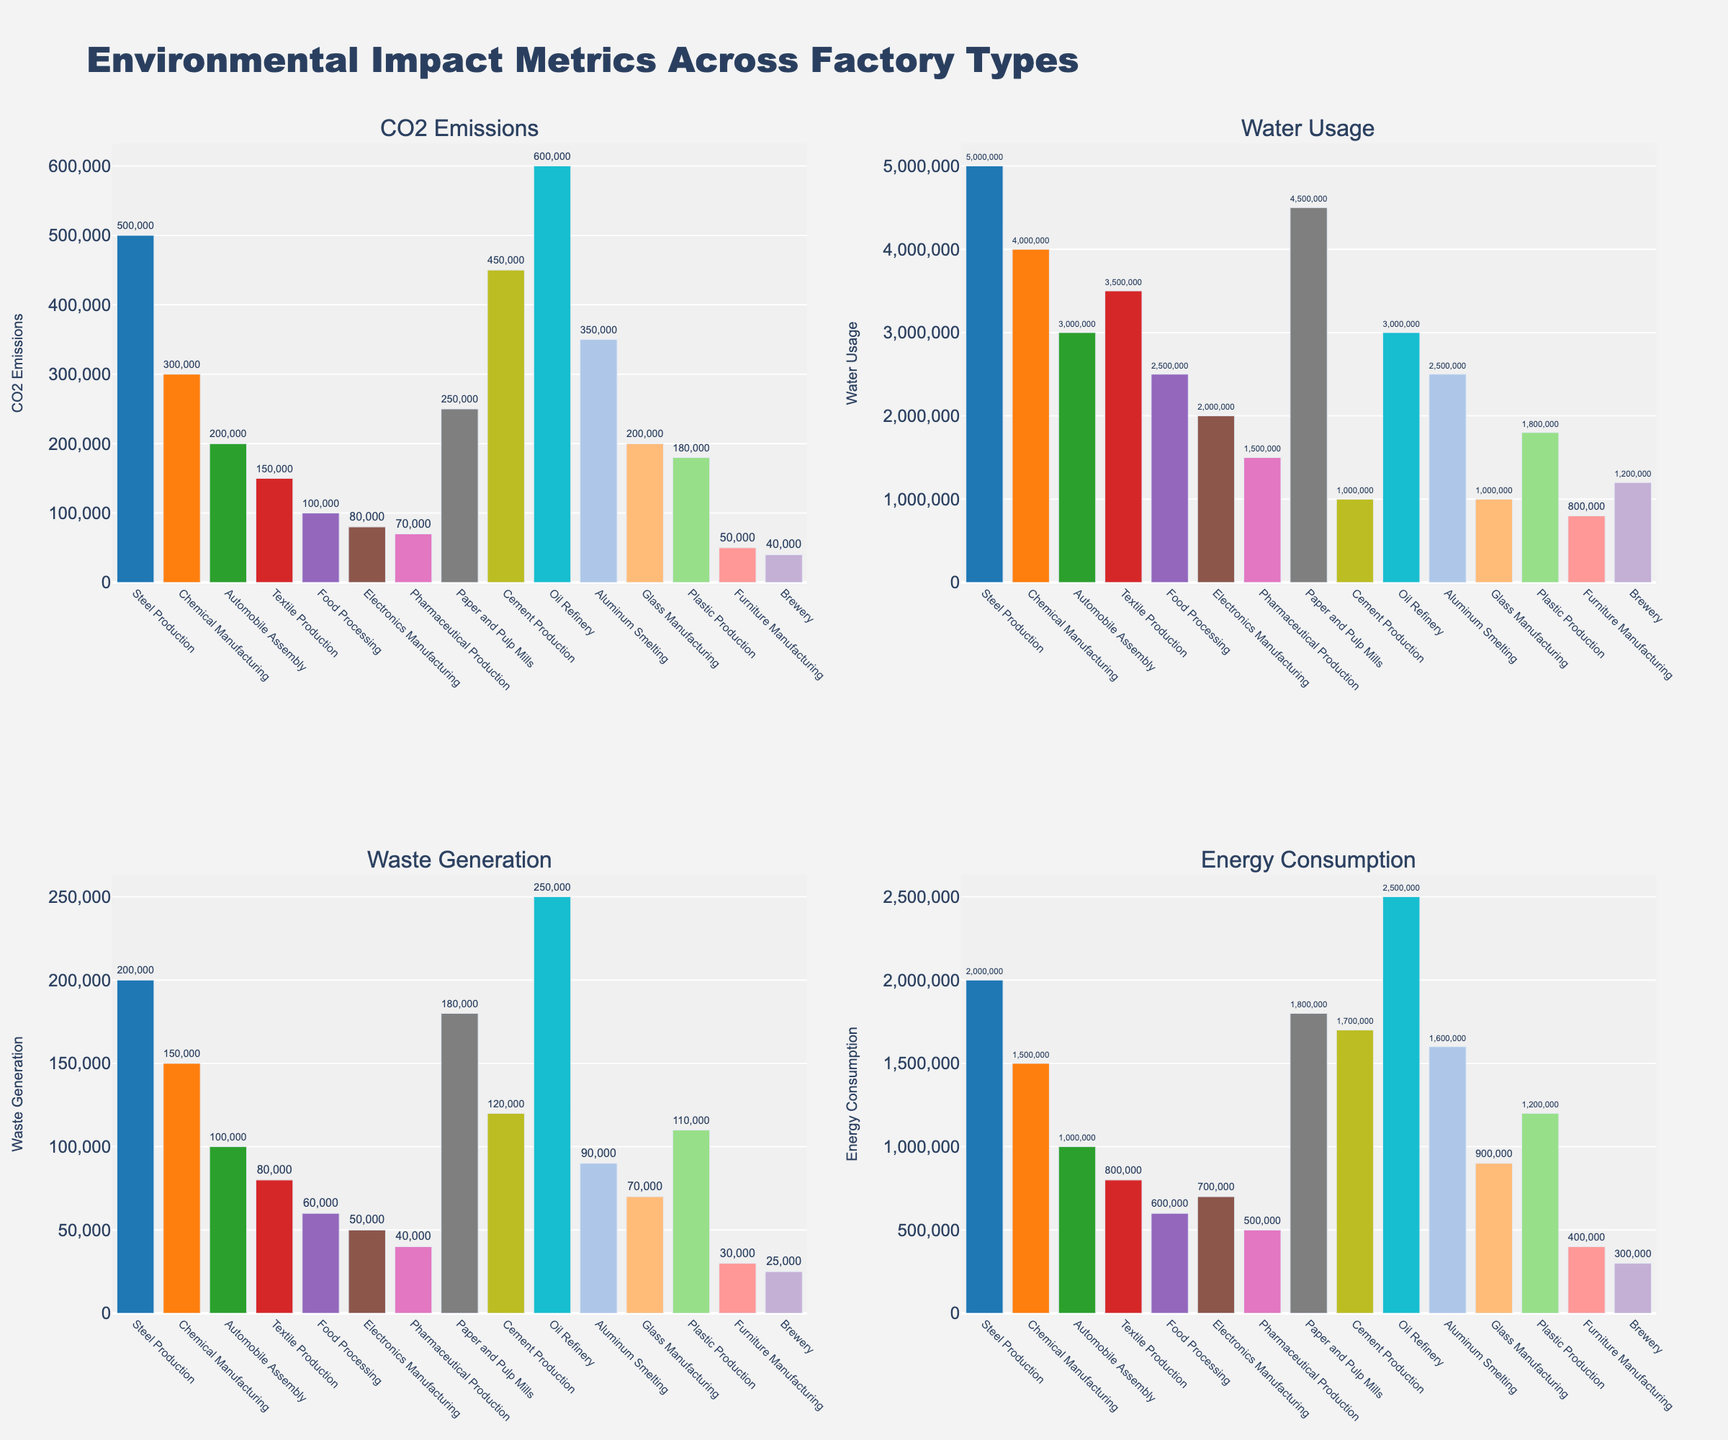What is the factory type with the highest CO2 emissions? By looking at the "CO2 Emissions" subplot, the factory type with the highest CO2 emissions is identified by the tallest bar in the chart.
Answer: Oil Refinery Which factory type uses the most water annually? The "Water Usage" subplot shows the water usage of each factory. The tallest bar represents the factory type with the highest water usage.
Answer: Steel Production How does the waste generation of Chemical Manufacturing compare to that of Textile Production? In the "Waste Generation" subplot, compare the heights of the bars for Chemical Manufacturing and Textile Production. Chemical Manufacturing has a taller bar than Textile Production, indicating higher waste generation.
Answer: Higher Which factory type has the lowest energy consumption? The "Energy Consumption" subplot shows the energy consumption of each factory type. The shortest bar represents the factory with the lowest energy consumption.
Answer: Brewery What's the average CO2 emissions of Steel Production and Cement Production? Sum the CO2 emissions of Steel Production (500,000 tons/year) and Cement Production (450,000 tons/year) and divide by 2. Calculation: (500,000 + 450,000) / 2
Answer: 475,000 tons/year Which factory type generates more waste: Electronics Manufacturing or Plastic Production? In the "Waste Generation" subplot, compare the bars for Electronics Manufacturing and Plastic Production. The bar for Plastic Production is taller, indicating higher waste generation.
Answer: Plastic Production What is the difference in water usage between Automobile Assembly and Food Processing? Subtract the water usage of Food Processing (2,500,000 m3/year) from Automobile Assembly (3,000,000 m3/year). Calculation: 3,000,000 - 2,500,000
Answer: 500,000 m3/year How many factory types have CO2 emissions lower than 100,000 tons/year? Count the bars in the "CO2 Emissions" subplot that are shorter than the bar representing 100,000 tons/year emissions. There are three of them: Furniture Manufacturing, Brewery, and Pharmaceutical Production.
Answer: 3 Which factory type has a similar energy consumption to Cement Production? In the "Energy Consumption" subplot, identify the bar heights. The bar for Aluminum Smelting is similar to Cement Production, indicating similar energy consumption.
Answer: Aluminum Smelting What’s the sum of waste generated by Paper and Pulp Mills, Chemical Manufacturing, and Aluminum Smelting? Sum the waste generated by these factory types: Paper and Pulp Mills (180,000 tons/year), Chemical Manufacturing (150,000 tons/year), and Aluminum Smelting (90,000 tons/year). Calculation: 180,000 + 150,000 + 90,000
Answer: 420,000 tons/year 